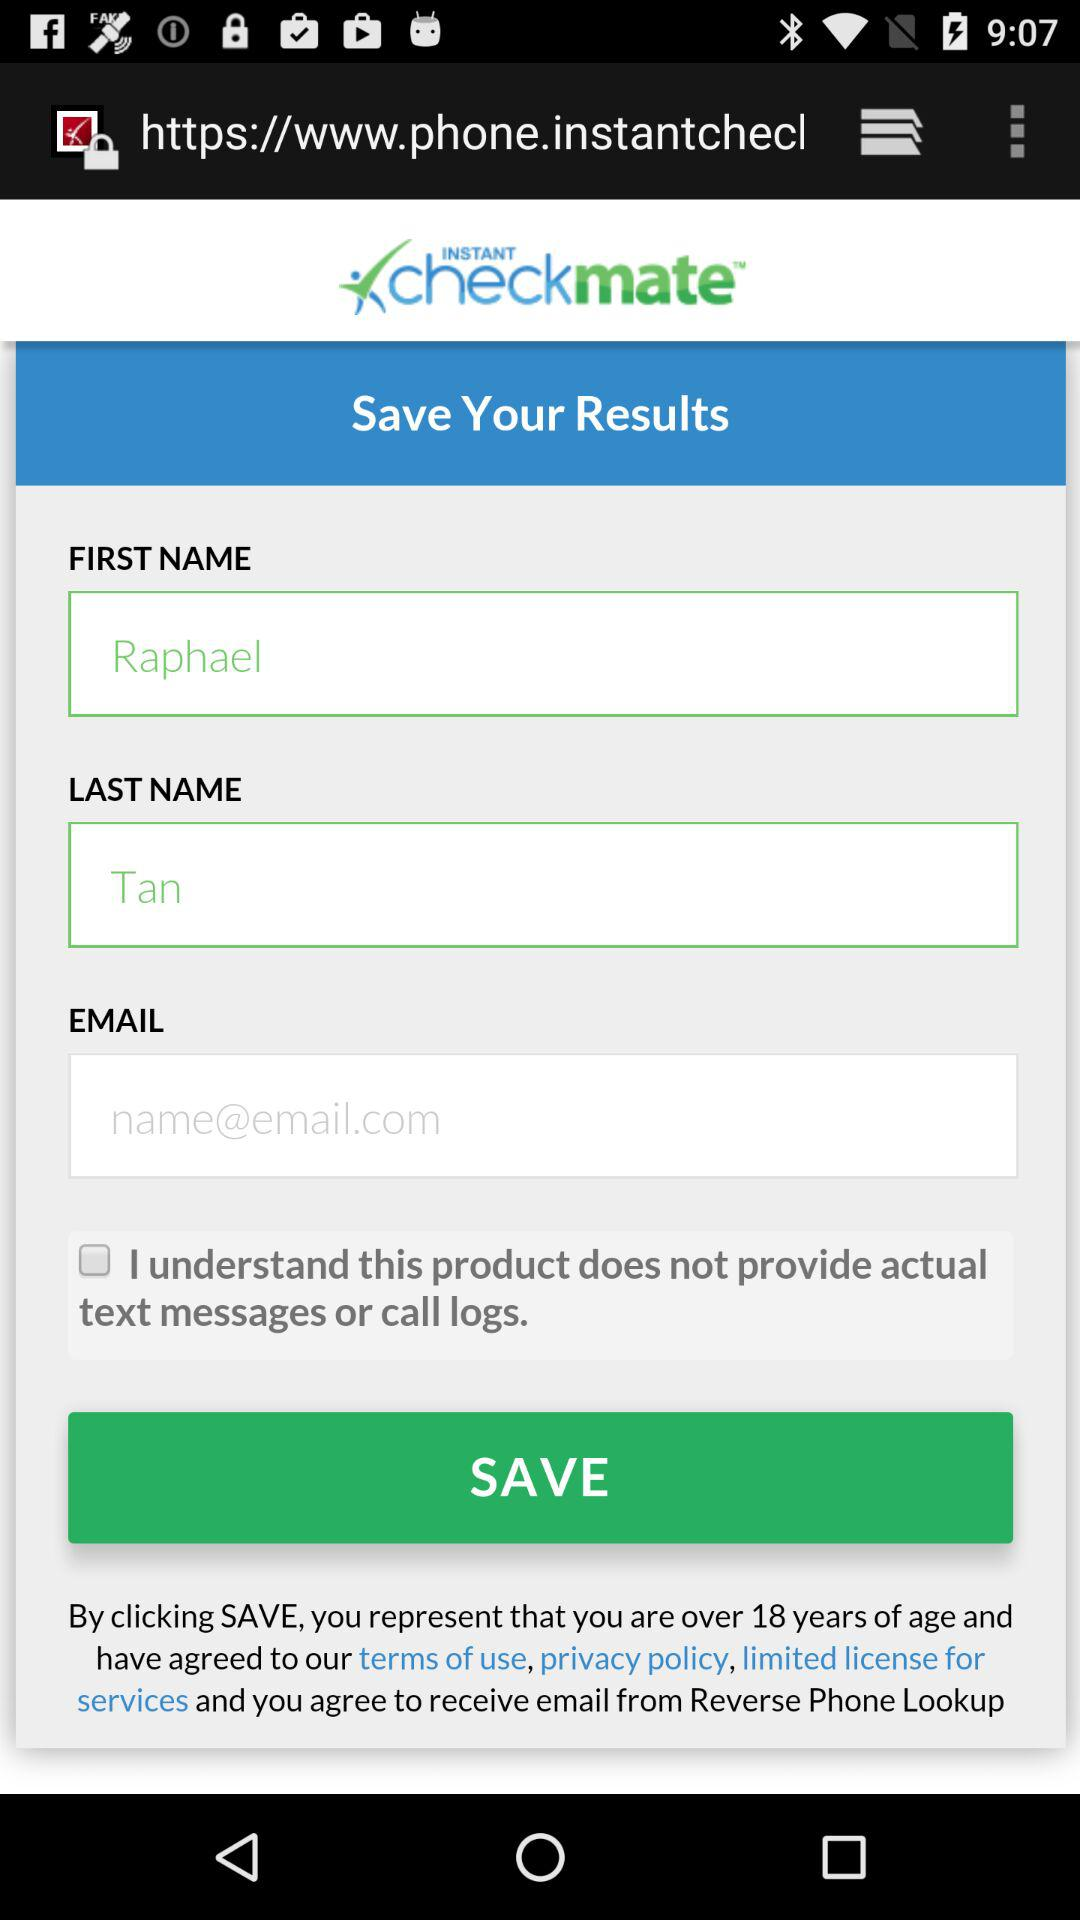What is the application name? The application name is "INSTANT checkmate". 